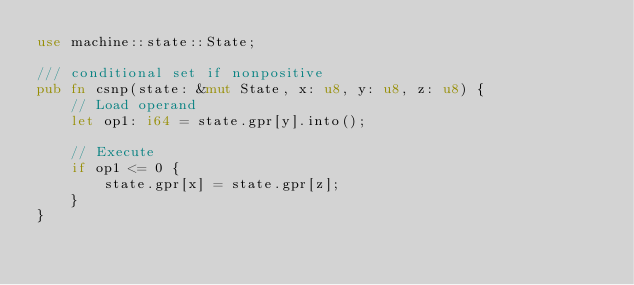Convert code to text. <code><loc_0><loc_0><loc_500><loc_500><_Rust_>use machine::state::State;

/// conditional set if nonpositive
pub fn csnp(state: &mut State, x: u8, y: u8, z: u8) {
    // Load operand
    let op1: i64 = state.gpr[y].into();

    // Execute
    if op1 <= 0 {
        state.gpr[x] = state.gpr[z];
    }
}
</code> 